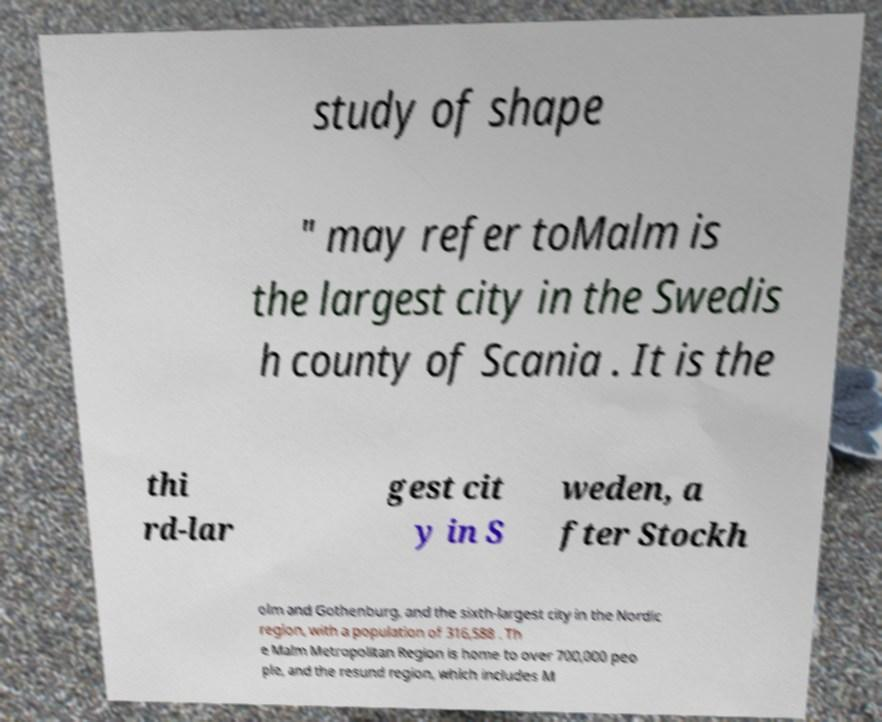I need the written content from this picture converted into text. Can you do that? study of shape " may refer toMalm is the largest city in the Swedis h county of Scania . It is the thi rd-lar gest cit y in S weden, a fter Stockh olm and Gothenburg, and the sixth-largest city in the Nordic region, with a population of 316,588 . Th e Malm Metropolitan Region is home to over 700,000 peo ple, and the resund region, which includes M 